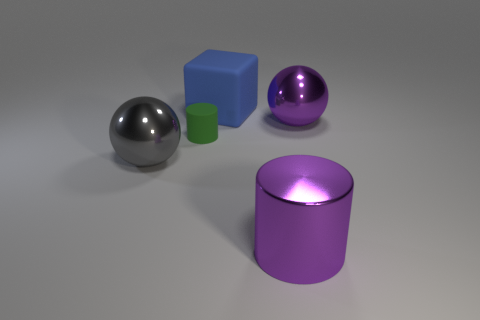Add 2 purple things. How many objects exist? 7 Subtract all balls. How many objects are left? 3 Add 5 large matte blocks. How many large matte blocks are left? 6 Add 1 big cubes. How many big cubes exist? 2 Subtract 0 brown blocks. How many objects are left? 5 Subtract all small red objects. Subtract all large purple metal cylinders. How many objects are left? 4 